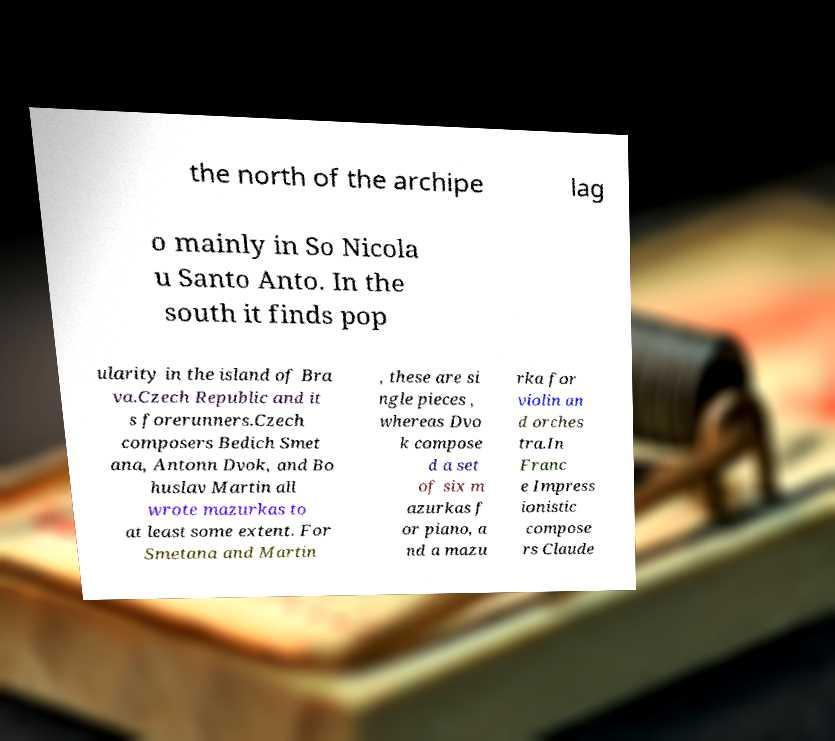What messages or text are displayed in this image? I need them in a readable, typed format. the north of the archipe lag o mainly in So Nicola u Santo Anto. In the south it finds pop ularity in the island of Bra va.Czech Republic and it s forerunners.Czech composers Bedich Smet ana, Antonn Dvok, and Bo huslav Martin all wrote mazurkas to at least some extent. For Smetana and Martin , these are si ngle pieces , whereas Dvo k compose d a set of six m azurkas f or piano, a nd a mazu rka for violin an d orches tra.In Franc e Impress ionistic compose rs Claude 